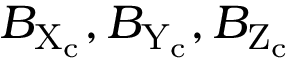Convert formula to latex. <formula><loc_0><loc_0><loc_500><loc_500>B _ { X _ { c } } , B _ { Y _ { c } } , B _ { Z _ { c } }</formula> 